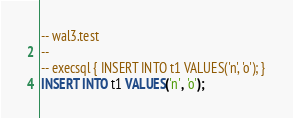<code> <loc_0><loc_0><loc_500><loc_500><_SQL_>-- wal3.test
-- 
-- execsql { INSERT INTO t1 VALUES('n', 'o'); }
INSERT INTO t1 VALUES('n', 'o');</code> 